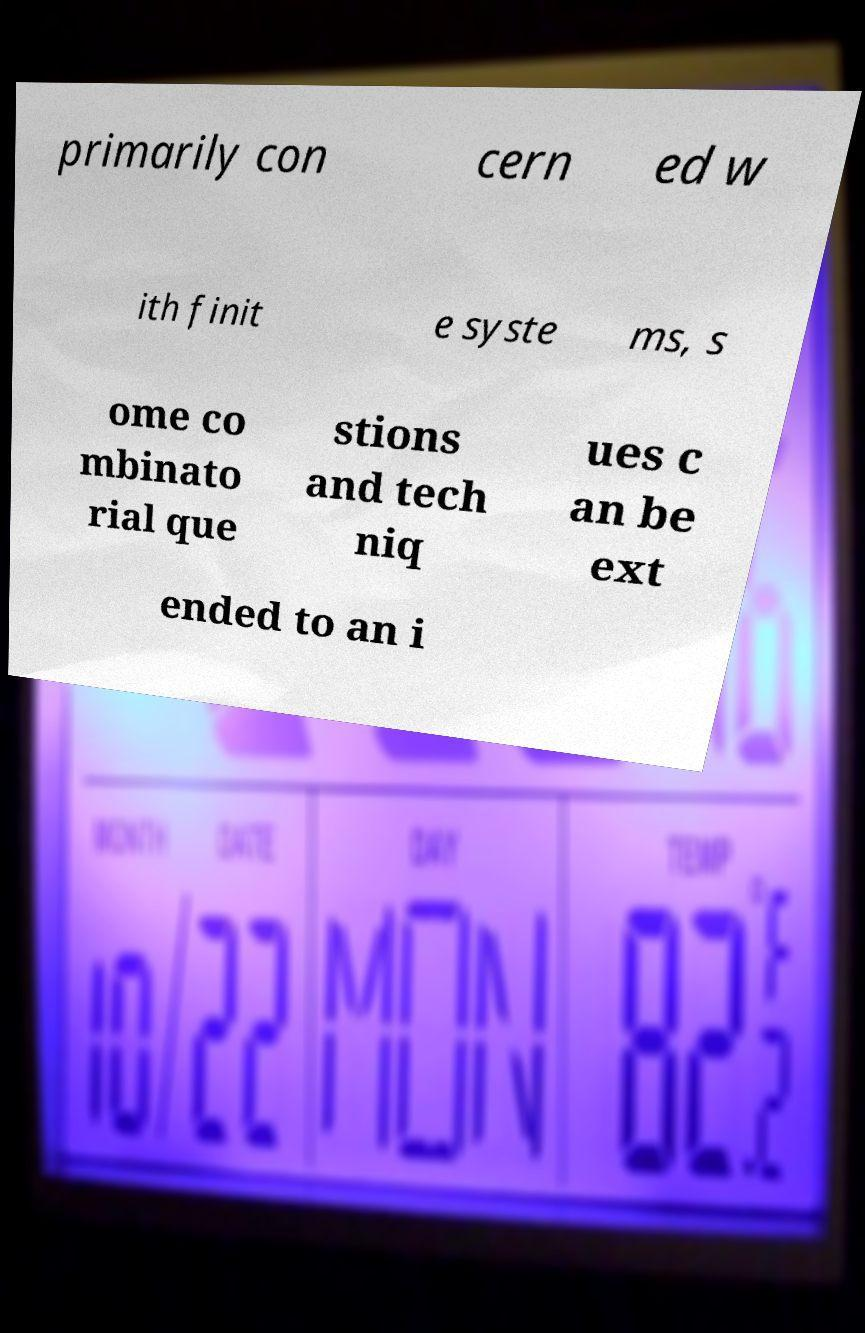There's text embedded in this image that I need extracted. Can you transcribe it verbatim? primarily con cern ed w ith finit e syste ms, s ome co mbinato rial que stions and tech niq ues c an be ext ended to an i 